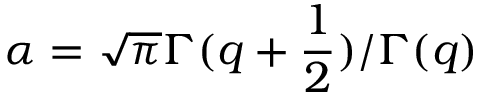Convert formula to latex. <formula><loc_0><loc_0><loc_500><loc_500>\alpha = \sqrt { \pi } \Gamma ( q + \frac { 1 } { 2 } ) / \Gamma ( q )</formula> 